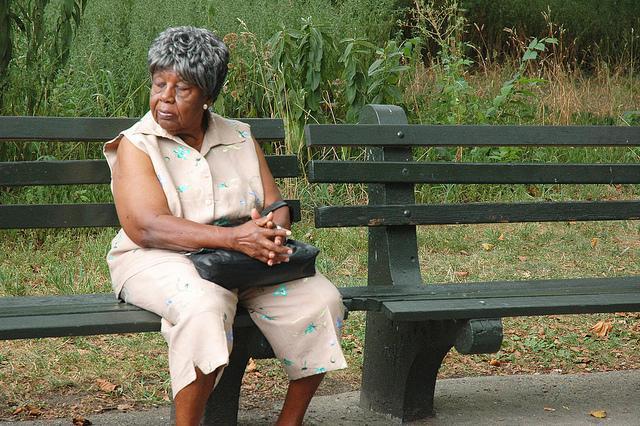What activity is the old lady engaging in?
Choose the correct response, then elucidate: 'Answer: answer
Rationale: rationale.'
Options: Resting, crying, sleeping, praying. Answer: resting.
Rationale: She is sitting. 